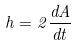Convert formula to latex. <formula><loc_0><loc_0><loc_500><loc_500>h = 2 \frac { d A } { d t }</formula> 